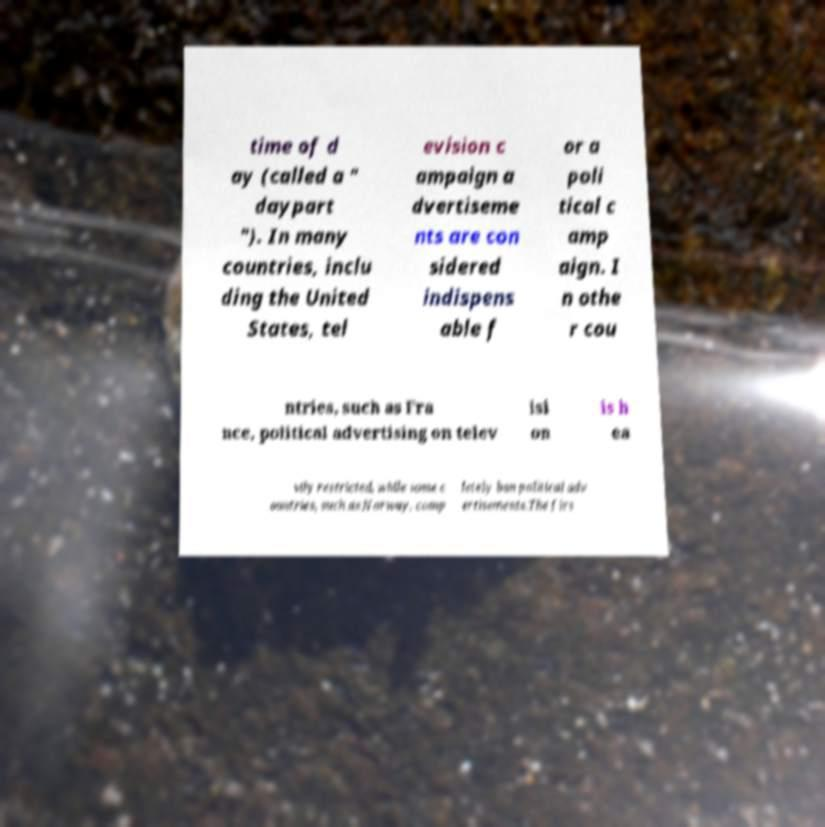Can you read and provide the text displayed in the image?This photo seems to have some interesting text. Can you extract and type it out for me? time of d ay (called a " daypart "). In many countries, inclu ding the United States, tel evision c ampaign a dvertiseme nts are con sidered indispens able f or a poli tical c amp aign. I n othe r cou ntries, such as Fra nce, political advertising on telev isi on is h ea vily restricted, while some c ountries, such as Norway, comp letely ban political adv ertisements.The firs 